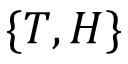<formula> <loc_0><loc_0><loc_500><loc_500>\{ T , H \}</formula> 